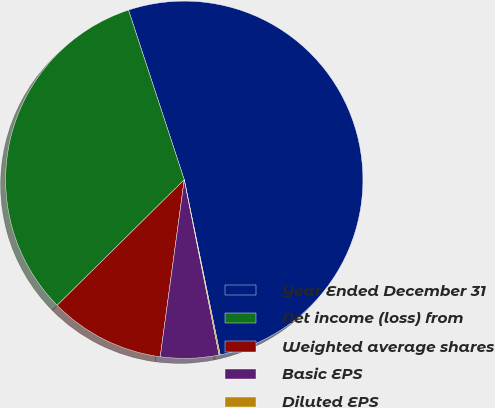Convert chart to OTSL. <chart><loc_0><loc_0><loc_500><loc_500><pie_chart><fcel>Year Ended December 31<fcel>Net income (loss) from<fcel>Weighted average shares<fcel>Basic EPS<fcel>Diluted EPS<nl><fcel>51.83%<fcel>32.35%<fcel>10.45%<fcel>5.27%<fcel>0.1%<nl></chart> 